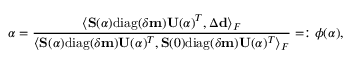<formula> <loc_0><loc_0><loc_500><loc_500>\alpha = \frac { \langle S ( \alpha ) d i a g ( \delta m ) U ( \alpha ) ^ { T } , \Delta d \rangle _ { F } } { \langle S ( \alpha ) d i a g ( \delta m ) U ( \alpha ) ^ { T } , S ( 0 ) d i a g ( \delta m ) U ( \alpha ) ^ { T } \rangle _ { F } } = \colon \phi ( \alpha ) ,</formula> 